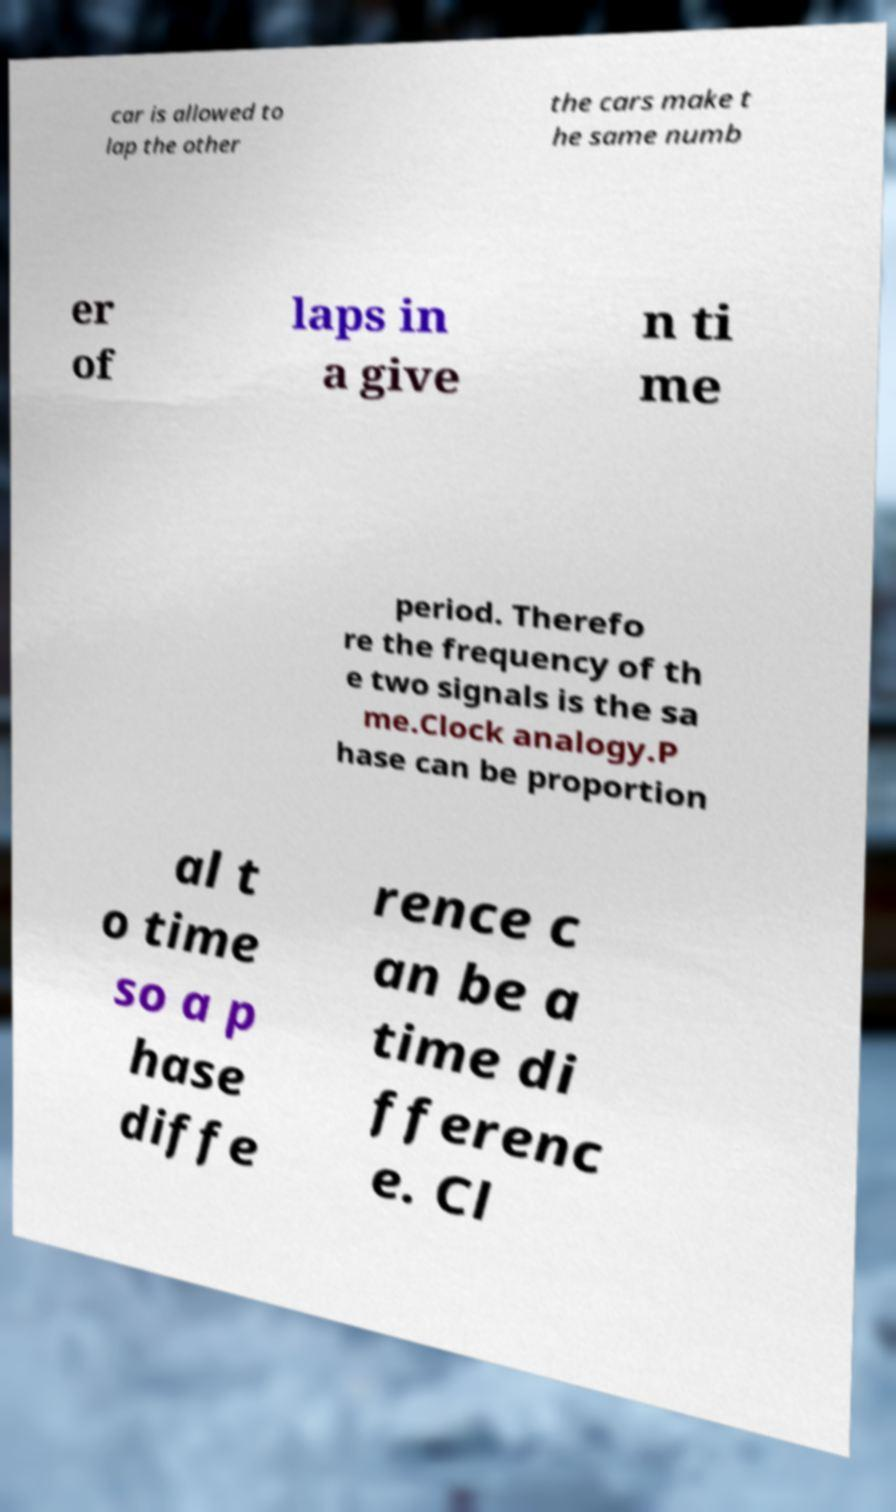Could you extract and type out the text from this image? car is allowed to lap the other the cars make t he same numb er of laps in a give n ti me period. Therefo re the frequency of th e two signals is the sa me.Clock analogy.P hase can be proportion al t o time so a p hase diffe rence c an be a time di fferenc e. Cl 